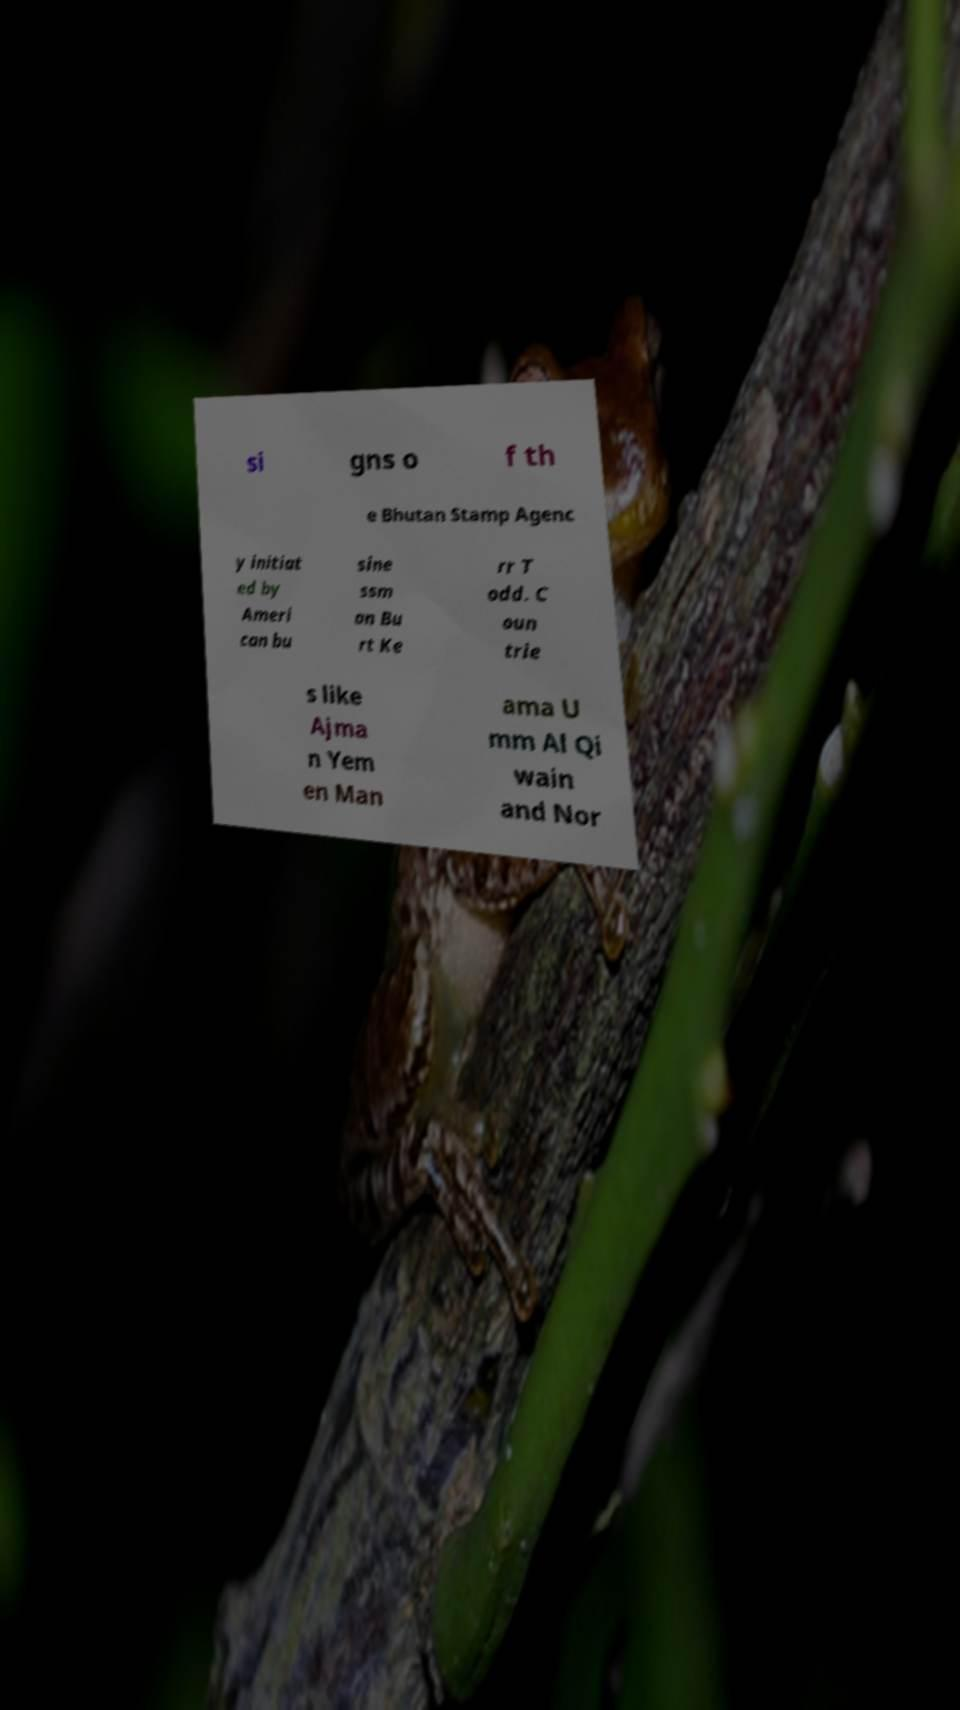Could you assist in decoding the text presented in this image and type it out clearly? si gns o f th e Bhutan Stamp Agenc y initiat ed by Ameri can bu sine ssm an Bu rt Ke rr T odd. C oun trie s like Ajma n Yem en Man ama U mm Al Qi wain and Nor 